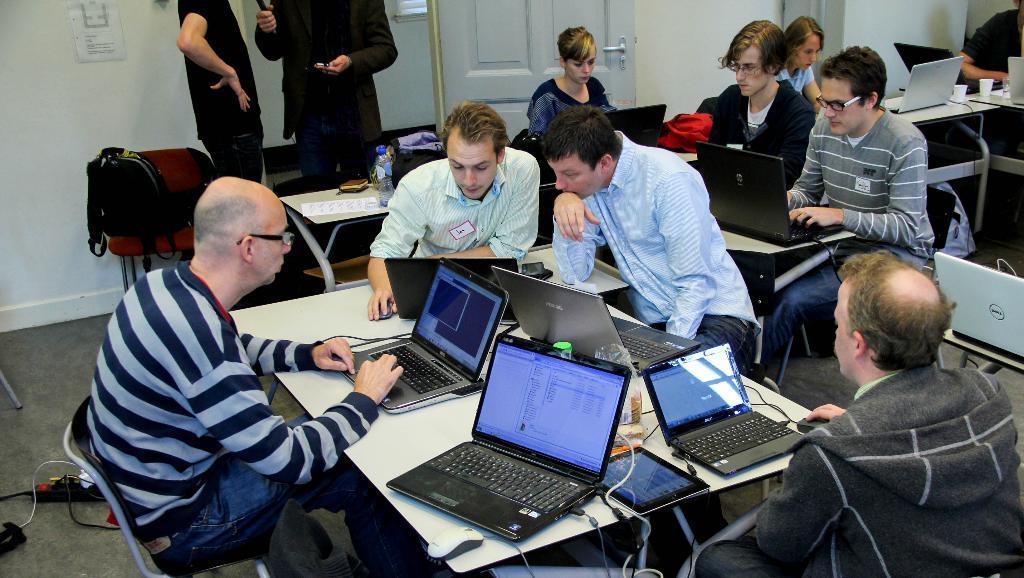Could you give a brief overview of what you see in this image? In this image we can see four men are sitting on the chairs. In front of them, we can see a table. On the table, we can see laptops, wires and some food items. On the right side of the image, we can see laptops on the table, men and women are sitting and doing work. At the top of the image, we can see a wall and a door. We can see two people are standing at the top of the image. We can see a paper on the wall. On the left side of the image, we can see a bag, chair, wires, carpet and an object. 